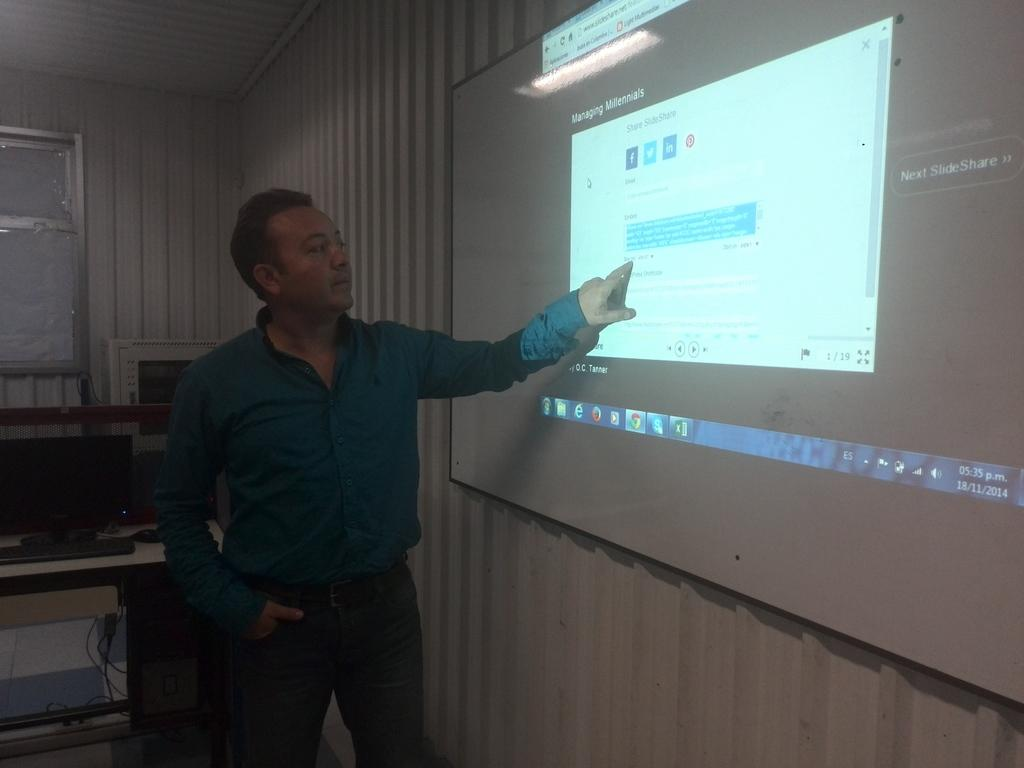<image>
Write a terse but informative summary of the picture. A man points at a screen showing a managing millennials presentation. 